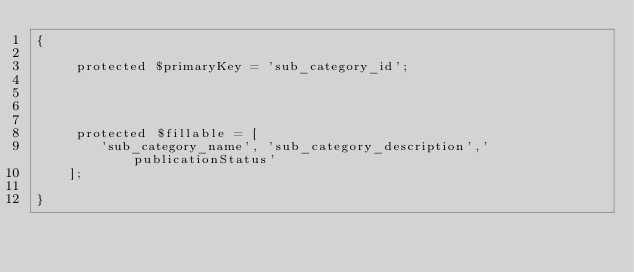Convert code to text. <code><loc_0><loc_0><loc_500><loc_500><_PHP_>{
    
     protected $primaryKey = 'sub_category_id';
     
     
     
    
     protected $fillable = [
        'sub_category_name', 'sub_category_description','publicationStatus' 
    ];
    
}
</code> 